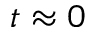Convert formula to latex. <formula><loc_0><loc_0><loc_500><loc_500>t \approx 0</formula> 